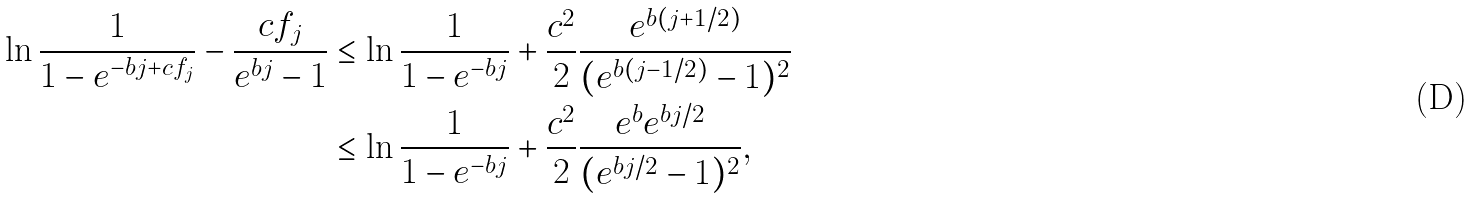Convert formula to latex. <formula><loc_0><loc_0><loc_500><loc_500>\ln \frac { 1 } { 1 - e ^ { - b j + c f _ { j } } } - \frac { c f _ { j } } { e ^ { b j } - 1 } & \leq \ln \frac { 1 } { 1 - e ^ { - b j } } + \frac { c ^ { 2 } } 2 \frac { e ^ { b ( j + 1 / 2 ) } } { ( e ^ { b ( j - 1 / 2 ) } - 1 ) ^ { 2 } } \\ & \leq \ln \frac { 1 } { 1 - e ^ { - b j } } + \frac { c ^ { 2 } } 2 \frac { e ^ { b } e ^ { b j / 2 } } { ( e ^ { b j / 2 } - 1 ) ^ { 2 } } ,</formula> 